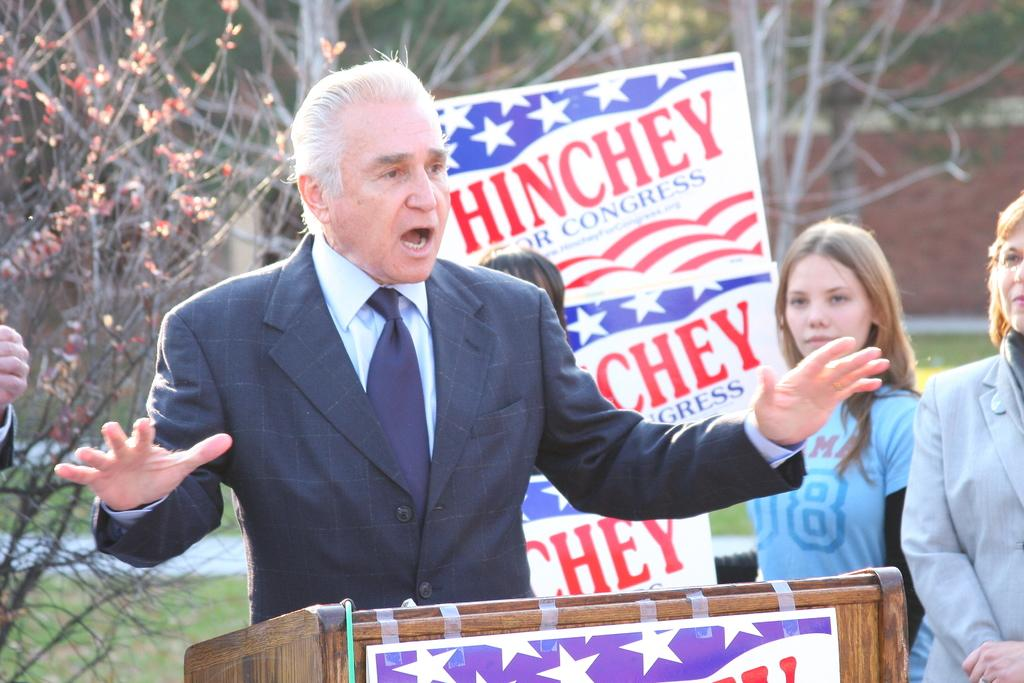What is the person in the image doing? The person is standing in front of a podium. Can you describe the people in the image? There are people visible in the image. What type of natural elements can be seen in the image? There are trees in the image. What objects are present in the image? There are boards and a wall in the image. What type of fruit is hanging from the tree in the image? There is no fruit visible in the image; only trees are mentioned. 